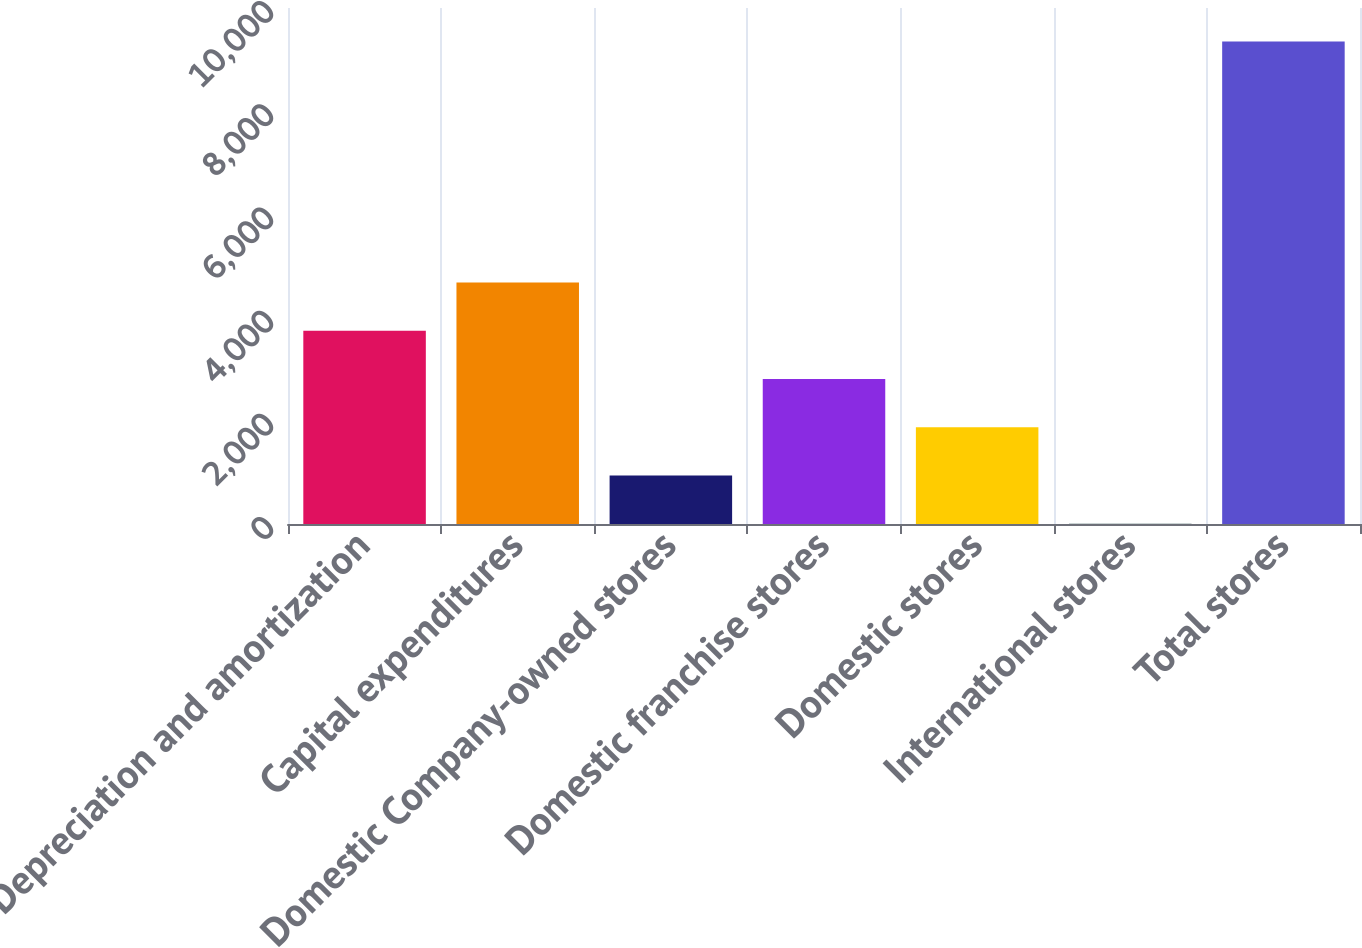Convert chart to OTSL. <chart><loc_0><loc_0><loc_500><loc_500><bar_chart><fcel>Depreciation and amortization<fcel>Capital expenditures<fcel>Domestic Company-owned stores<fcel>Domestic franchise stores<fcel>Domestic stores<fcel>International stores<fcel>Total stores<nl><fcel>3744.54<fcel>4678.95<fcel>941.31<fcel>2810.13<fcel>1875.72<fcel>6.9<fcel>9351<nl></chart> 